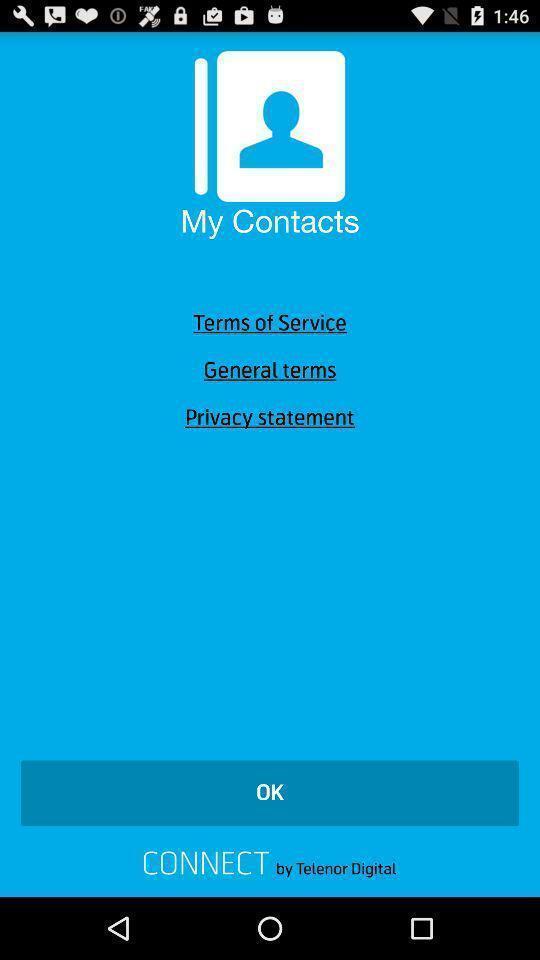Give me a summary of this screen capture. Screen shows multiple options in call application. 